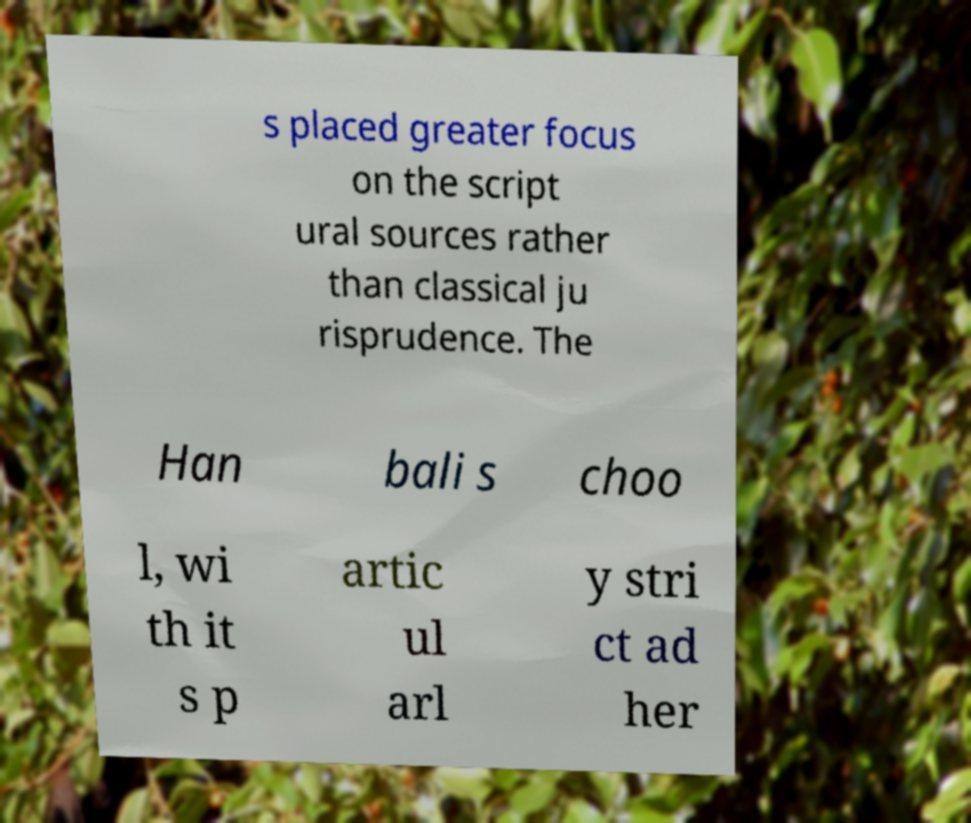For documentation purposes, I need the text within this image transcribed. Could you provide that? s placed greater focus on the script ural sources rather than classical ju risprudence. The Han bali s choo l, wi th it s p artic ul arl y stri ct ad her 